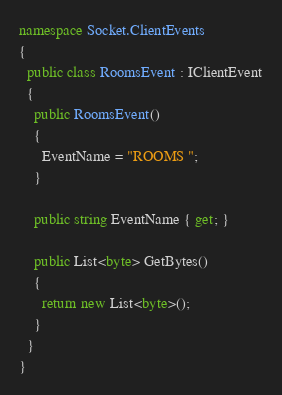<code> <loc_0><loc_0><loc_500><loc_500><_C#_>namespace Socket.ClientEvents
{
  public class RoomsEvent : IClientEvent
  {
    public RoomsEvent()
    {
      EventName = "ROOMS ";
    }

    public string EventName { get; }

    public List<byte> GetBytes()
    {
      return new List<byte>();
    }
  }
}</code> 